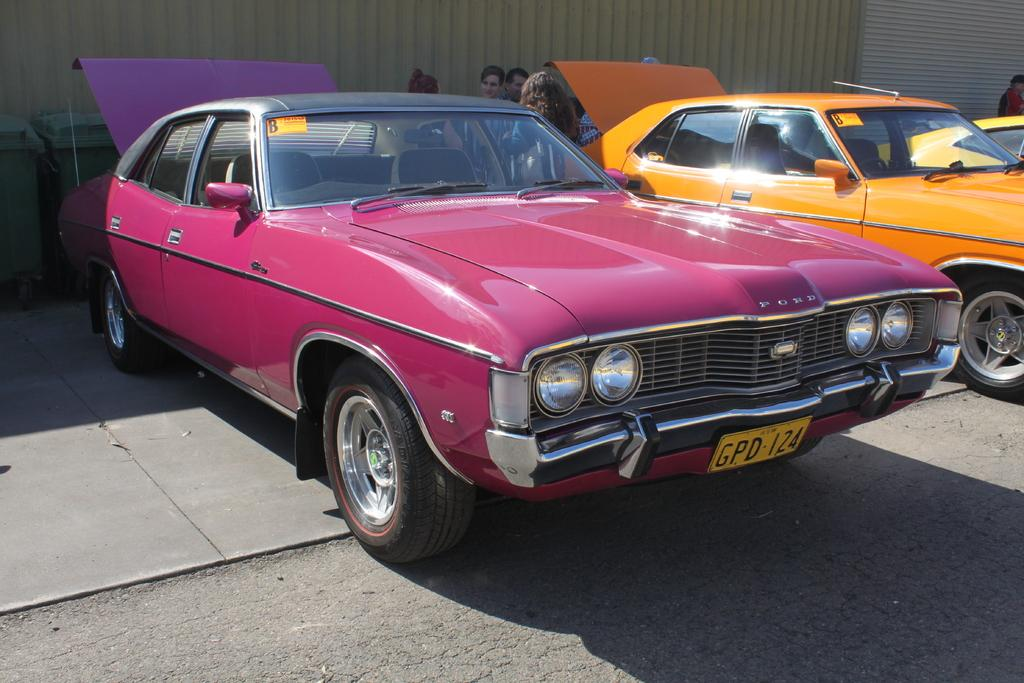What objects are parked on the floor in the image? There are cars parked on the floor in the image. What can be seen in the background of the image? There are persons standing in the background of the image. What type of structures are visible in the image? There are walls visible in the image. What items are present for waste disposal in the image? There are bins present in the image. What type of fiction is being read by the persons in the image? There is no indication of any reading material or persons reading in the image. 